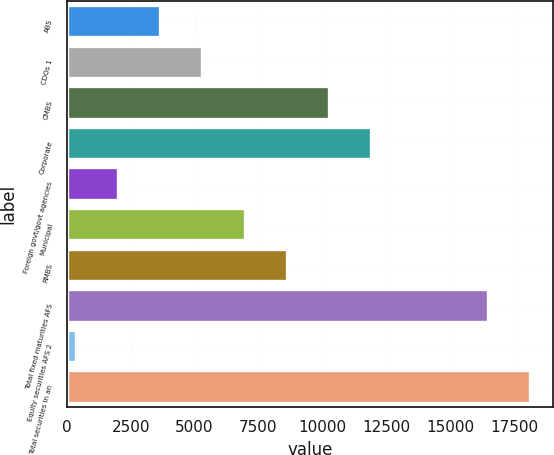Convert chart to OTSL. <chart><loc_0><loc_0><loc_500><loc_500><bar_chart><fcel>ABS<fcel>CDOs 1<fcel>CMBS<fcel>Corporate<fcel>Foreign govt/govt agencies<fcel>Municipal<fcel>RMBS<fcel>Total fixed maturities AFS<fcel>Equity securities AFS 2<fcel>Total securities in an<nl><fcel>3662.2<fcel>5309.3<fcel>10250.6<fcel>11897.7<fcel>2015.1<fcel>6956.4<fcel>8603.5<fcel>16471<fcel>368<fcel>18118.1<nl></chart> 